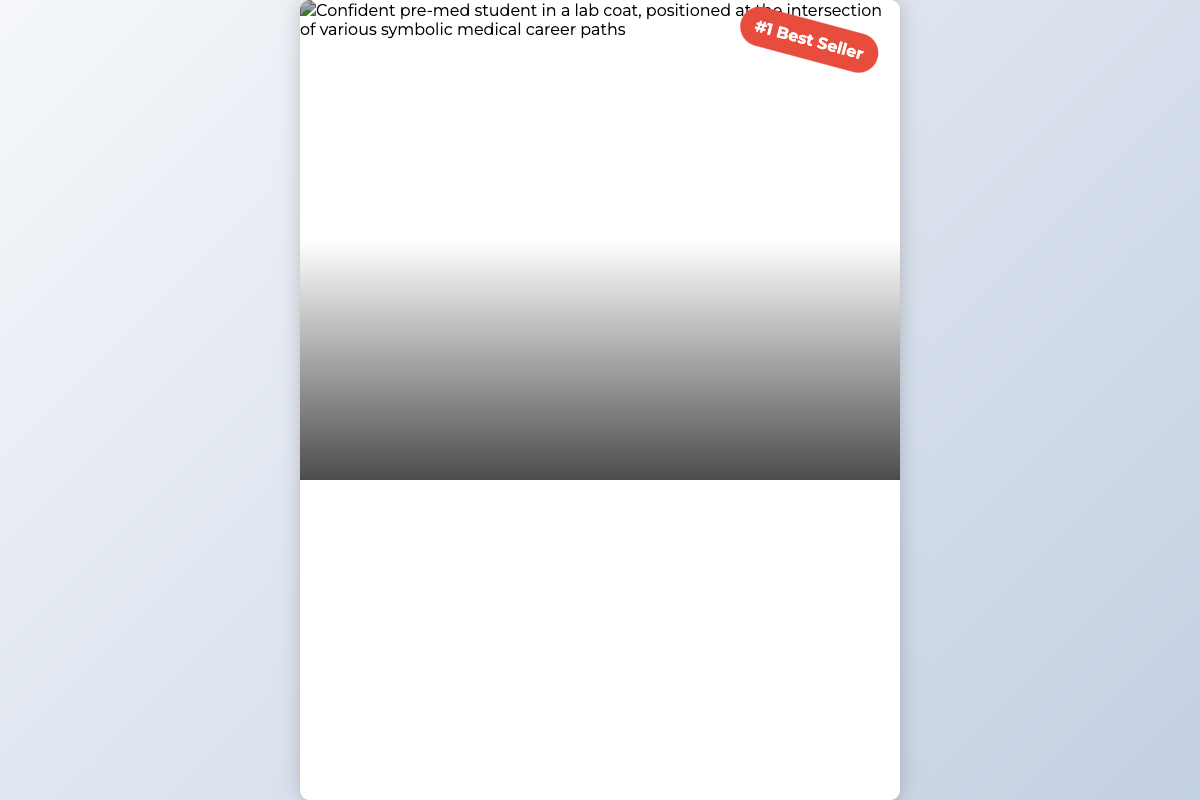What is the title of the book? The title is prominently displayed in the document and reads as follows.
Answer: Pre-Med Admissions: Strategies to Thrive in Your Journey to Medical School Who is the author of the book? The author's name is included in the content section of the cover.
Answer: Dr. Michelle Carter, M.D What type of visual does the book cover feature? The cover showcases a specific type of image representing a student.
Answer: Confident student in a lab coat What is noted as the book's status? There is a badge displayed that highlights the book's achievement.
Answer: #1 Best Seller What is the height of the book cover? The dimensions of the book cover are specified within the HTML structure.
Answer: 800px What is the genre of the book? The title hints at the book's main topic concerning a specific student pathway.
Answer: Pre-Med Education What is the format of the book cover? The document showcases a specific type of design element characteristic of a book cover.
Answer: Digital What is the theme of the book? The subtitle indicates the focus of the content related to medical school admissions.
Answer: Strategies to Thrive in Your Journey to Medical School What percentage of the cover height is the image container? The relative height allocation of the image section is defined within the style settings.
Answer: 60% 